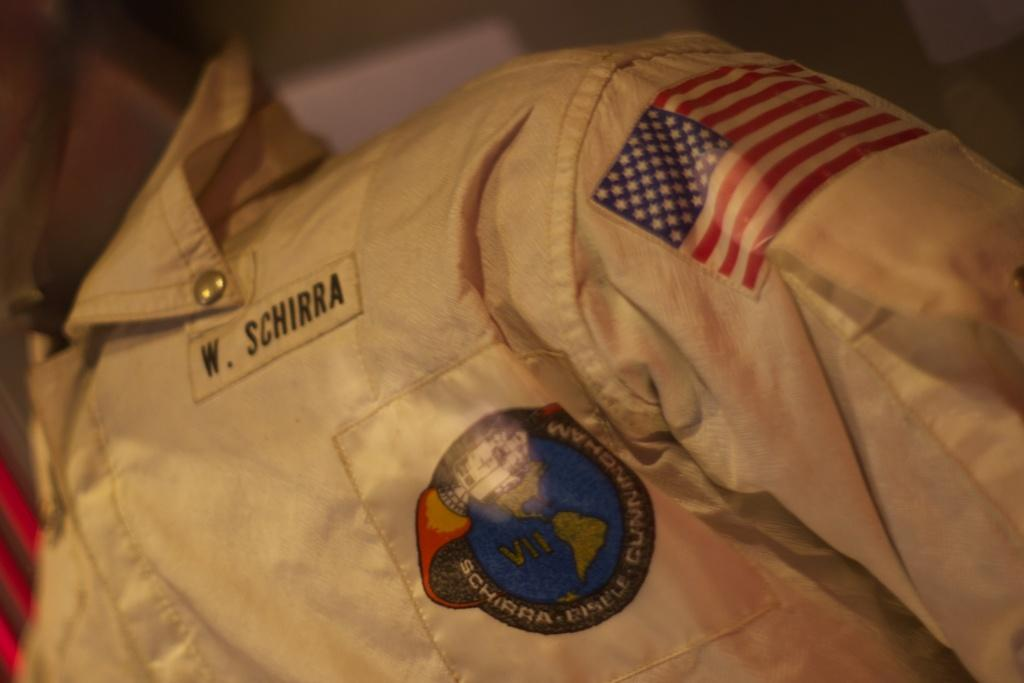What type of clothing is featured in the image? There is a golden jacket in the image. Is there any text or writing on the jacket? Yes, the jacket has the name "W. Schirra" on it. What can be seen in the background of the image? There is a wall visible in the image. How many snakes are slithering on the wall in the image? There are no snakes present in the image; the wall is visible but does not have any snakes on it. 